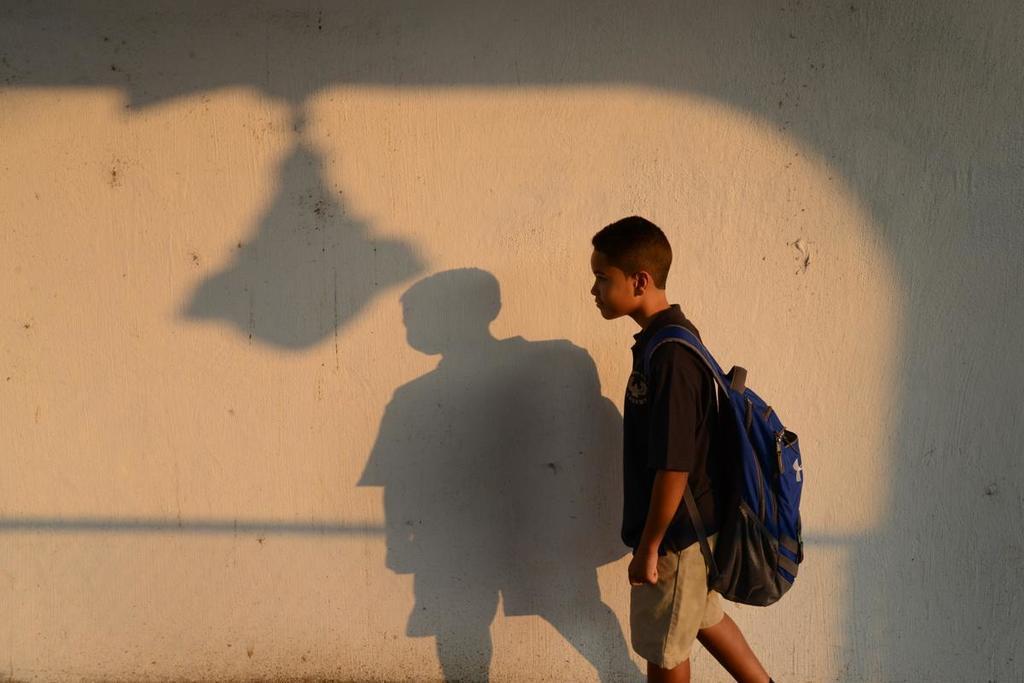How would you summarize this image in a sentence or two? In the foreground of this image, there is a boy walking and wearing a backpack. In the background, there is a wall and the shadows on it. 